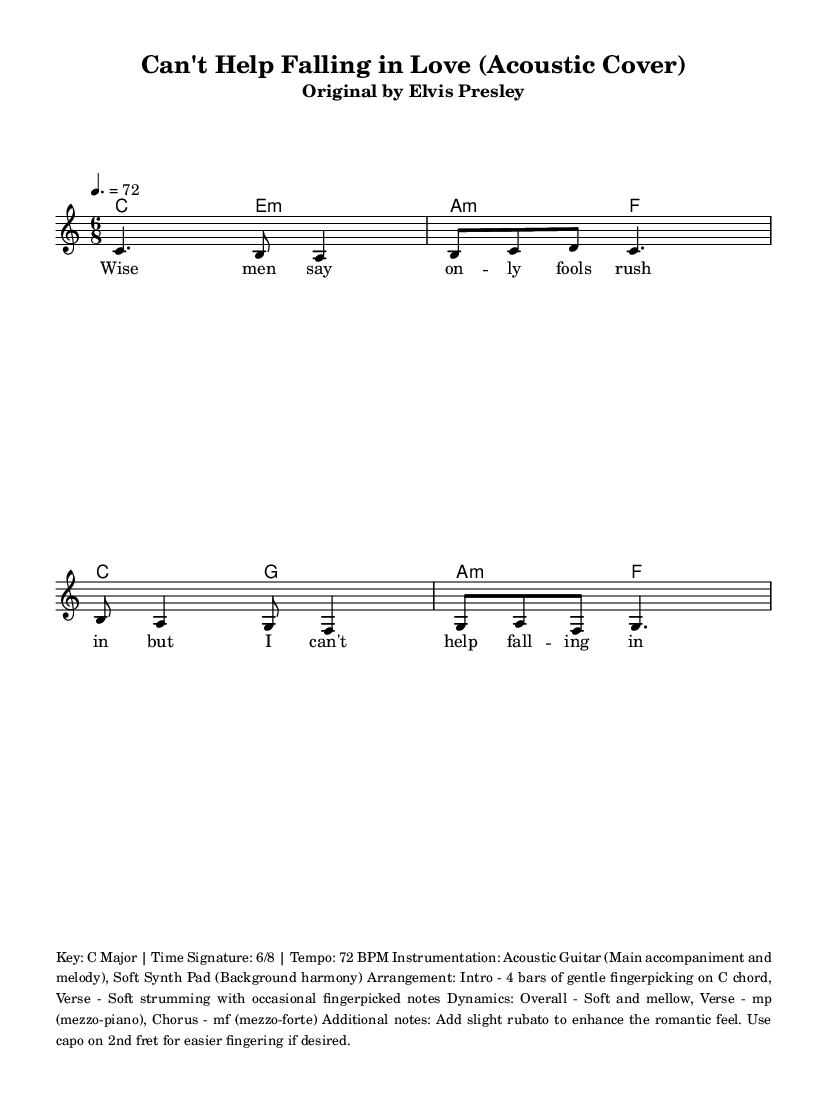What is the key signature of this music? The key signature is indicated at the beginning of the staff. It shows C major, which has no sharps or flats.
Answer: C major What is the time signature of this piece? The time signature appears near the beginning of the sheet music, indicating how many beats are in each measure. It is 6 over 8, meaning there are 6 eighth notes per measure.
Answer: 6/8 What is the tempo marking for this piece? The tempo marking is shown as a number with the note type beside it, which indicates how fast the music is played. Here it is set at a quarter note = 72 beats per minute.
Answer: 72 BPM What instrument is primarily featured in this arrangement? Looking at the instrumentation notes, the main instrumental focus is on the acoustic guitar, which is mentioned as the lead for both accompaniment and melody.
Answer: Acoustic Guitar What is the dynamic marking for the verse section? The dynamic marking can be identified in the additional notes section, which states that the overall dynamics should be soft and mellow, with specific mention of the verse being at mezzo-piano.
Answer: mp How should the musician approach the introduction of the piece? The additional notes specify that the introduction consists of 4 bars of gentle fingerpicking on the C chord. This indicates a specific playing style that sets the mood for the romantic theme.
Answer: Gentle fingerpicking on C chord What effect does the use of rubato have on this piece? The sheet music mentions to add slight rubato, which means to vary the tempo slightly to enhance emotional expression, typical in romantic music. This creates a more expressive and flexible performance.
Answer: Enhances romantic feel 